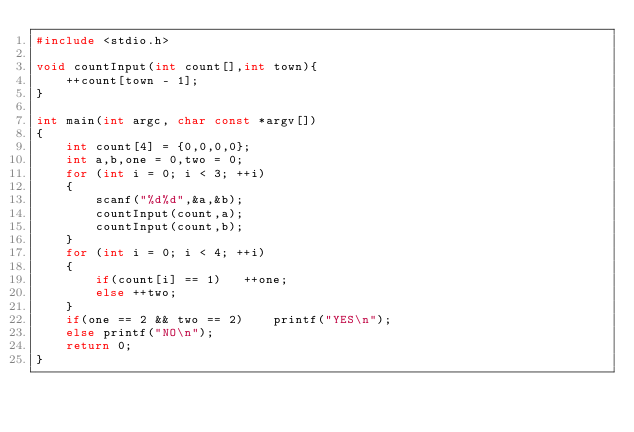<code> <loc_0><loc_0><loc_500><loc_500><_C_>#include <stdio.h>

void countInput(int count[],int town){
	++count[town - 1];
}

int main(int argc, char const *argv[])
{
	int count[4] = {0,0,0,0};
	int a,b,one = 0,two = 0;
	for (int i = 0; i < 3; ++i)
	{
		scanf("%d%d",&a,&b);
		countInput(count,a);
		countInput(count,b);
	}
	for (int i = 0; i < 4; ++i)
	{
		if(count[i] == 1)	++one;
		else ++two;
	}
	if(one == 2 && two == 2)	printf("YES\n");
	else printf("NO\n");
	return 0;
}</code> 